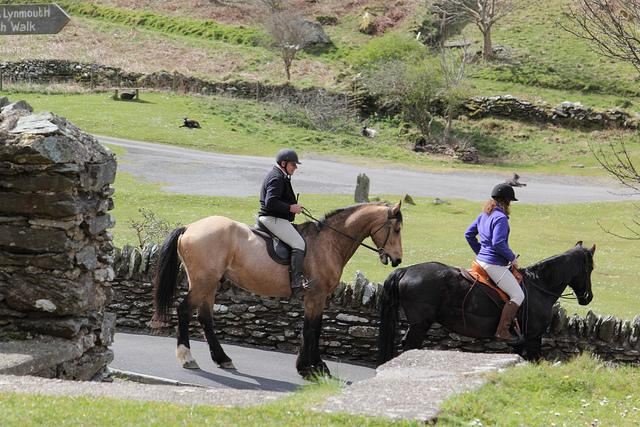What are the black helmets the people are wearing made for? Please explain your reasoning. riding. The men are on horses and have helmets on in case they fall. 